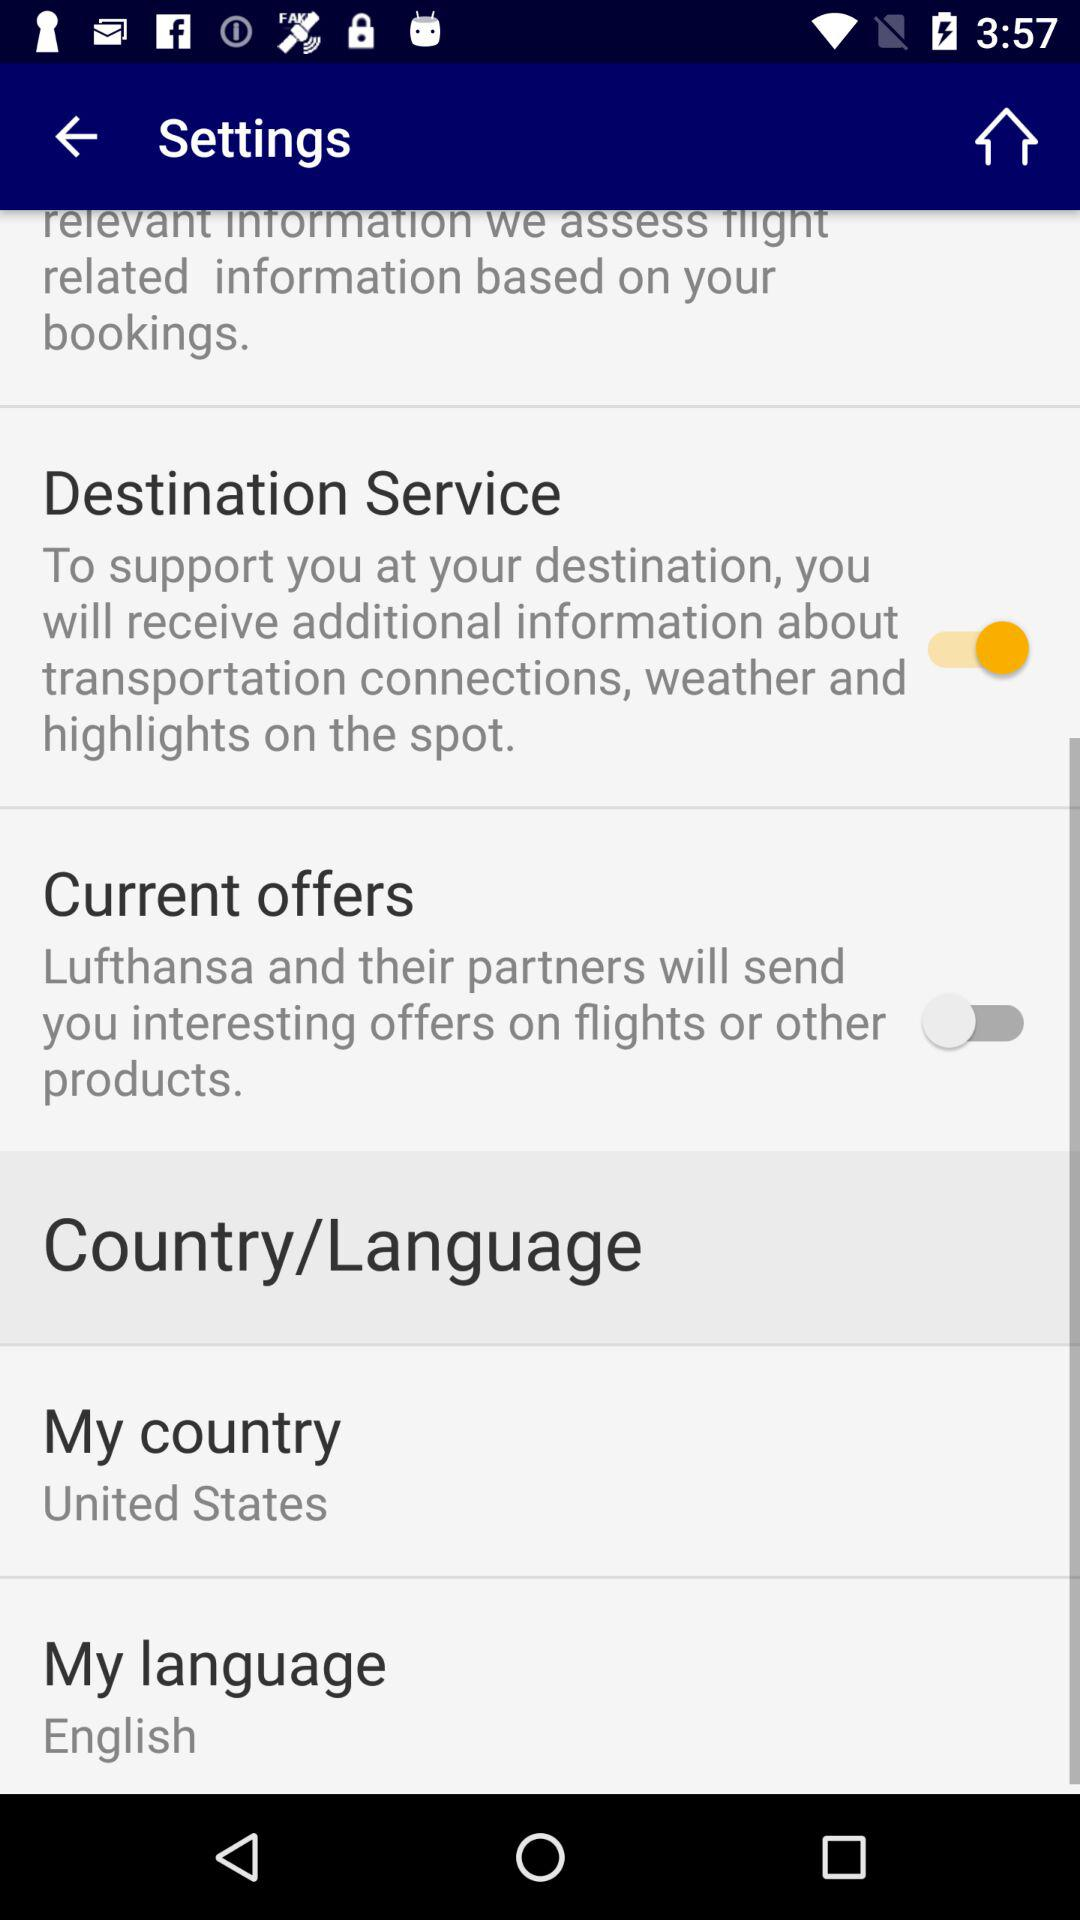What is the selected language? The selected language is "English". 